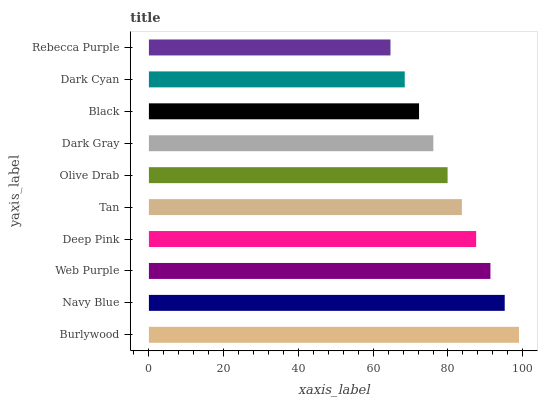Is Rebecca Purple the minimum?
Answer yes or no. Yes. Is Burlywood the maximum?
Answer yes or no. Yes. Is Navy Blue the minimum?
Answer yes or no. No. Is Navy Blue the maximum?
Answer yes or no. No. Is Burlywood greater than Navy Blue?
Answer yes or no. Yes. Is Navy Blue less than Burlywood?
Answer yes or no. Yes. Is Navy Blue greater than Burlywood?
Answer yes or no. No. Is Burlywood less than Navy Blue?
Answer yes or no. No. Is Tan the high median?
Answer yes or no. Yes. Is Olive Drab the low median?
Answer yes or no. Yes. Is Burlywood the high median?
Answer yes or no. No. Is Dark Gray the low median?
Answer yes or no. No. 